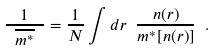<formula> <loc_0><loc_0><loc_500><loc_500>\frac { 1 } { \ \overline { m ^ { * } } \ } = \frac { 1 } { N } \int d { r } \ \frac { n ( { r } ) } { m ^ { * } [ n ( { r } ) ] } \ .</formula> 